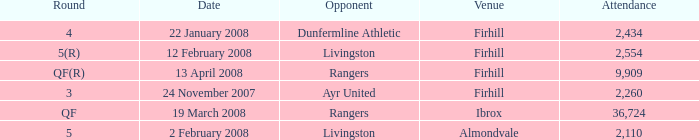What is the average attendance at a game held at Firhill for the 5(r) round? 2554.0. 